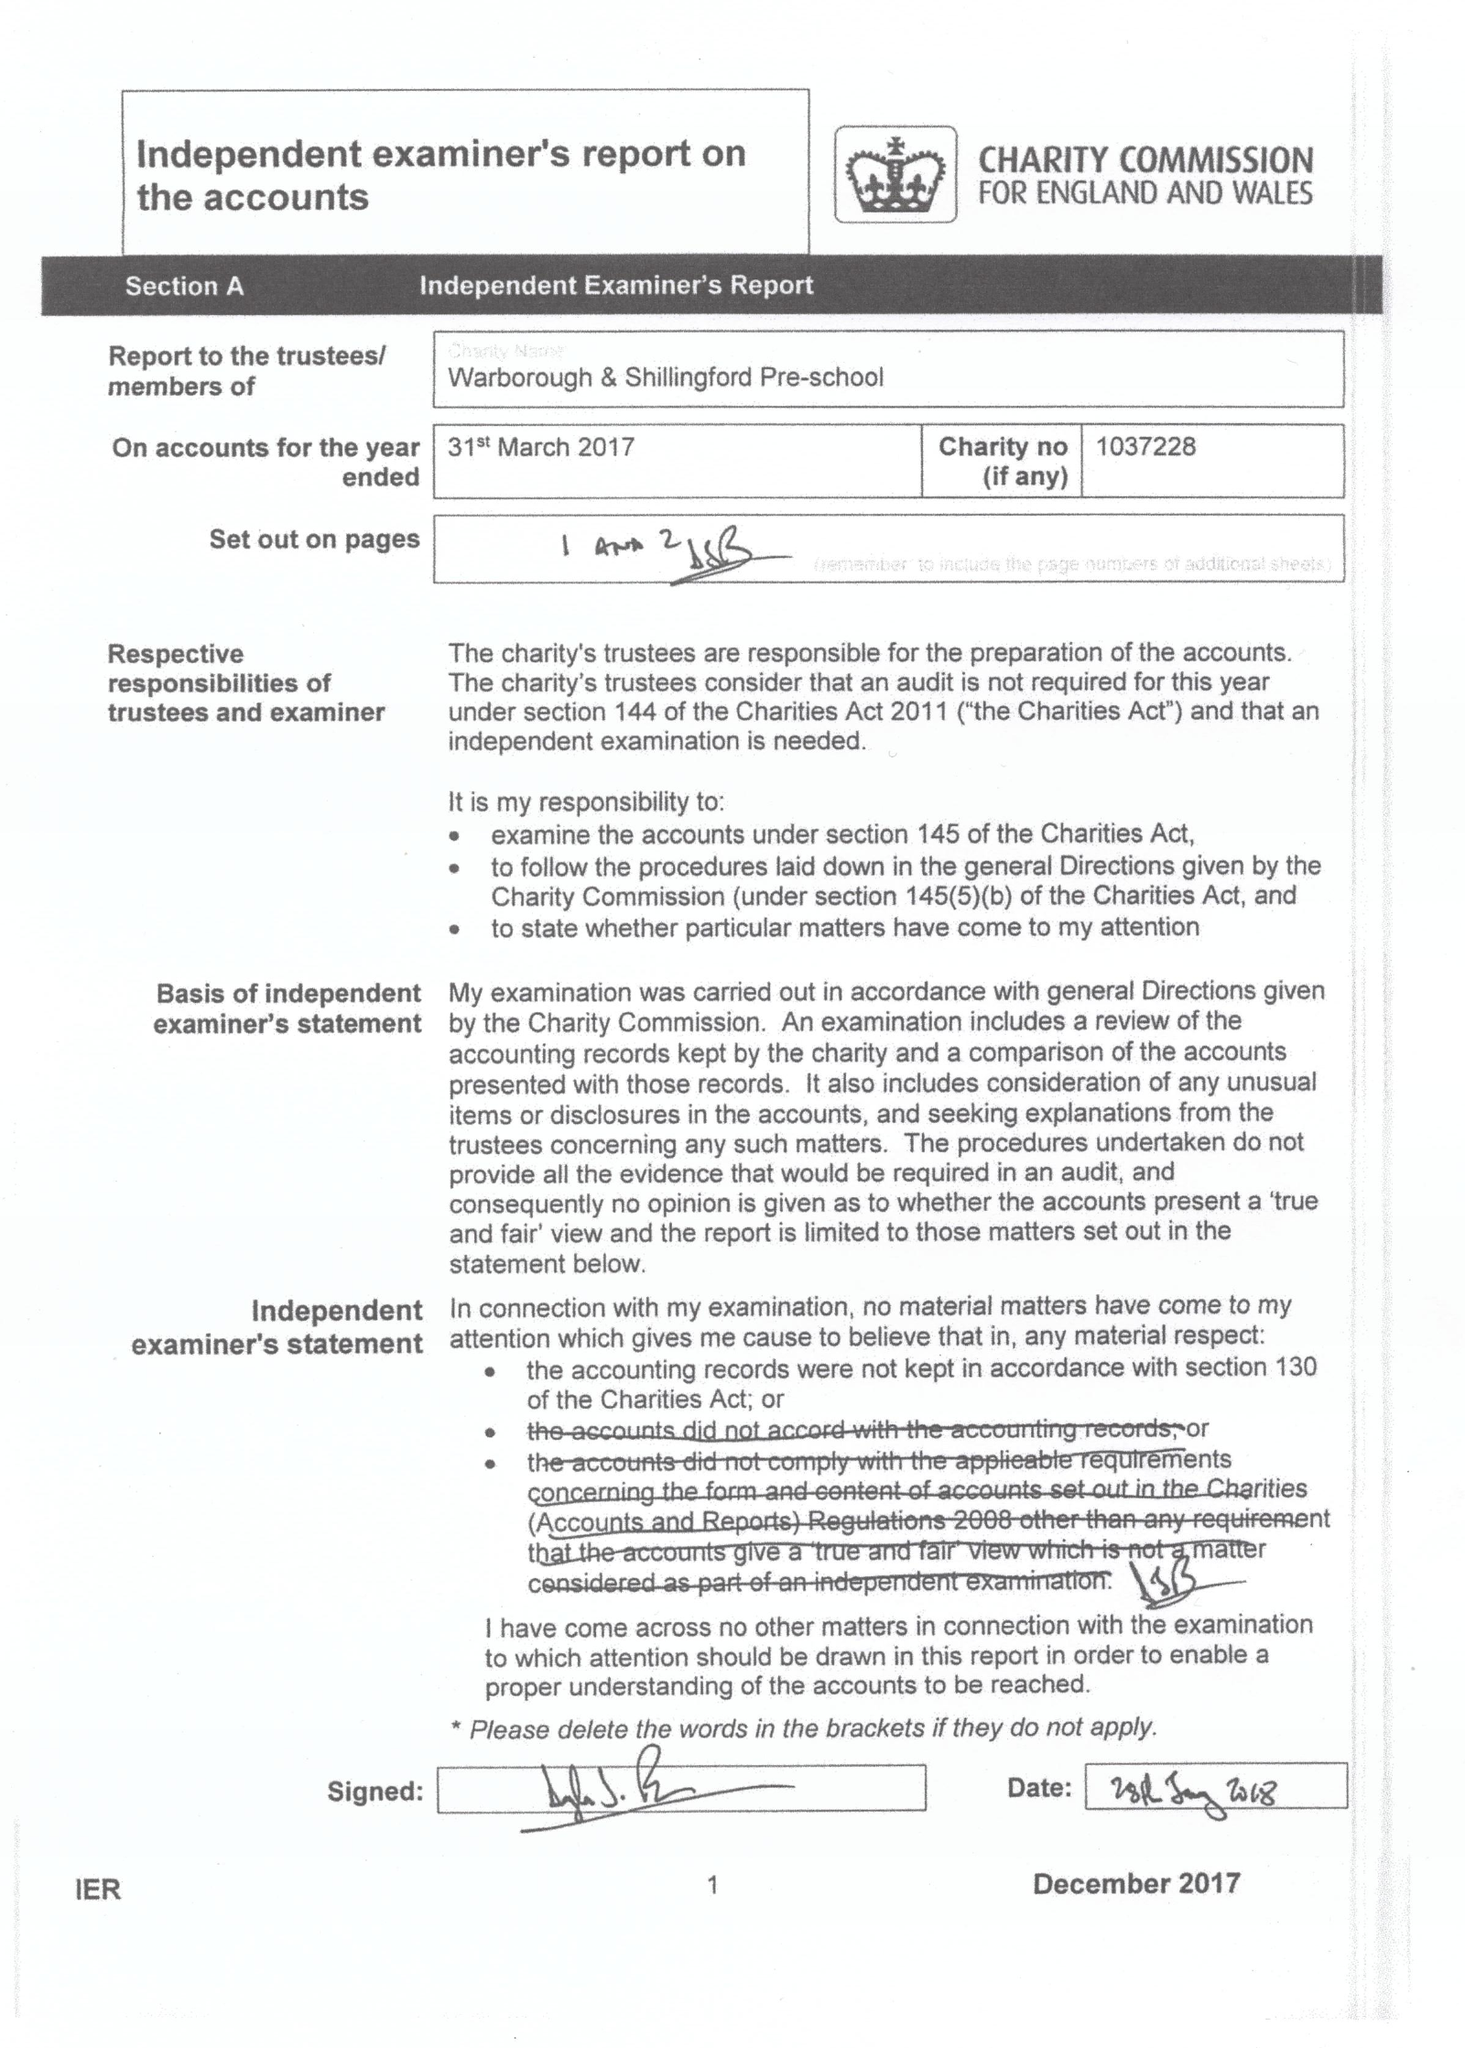What is the value for the report_date?
Answer the question using a single word or phrase. 2017-03-31 